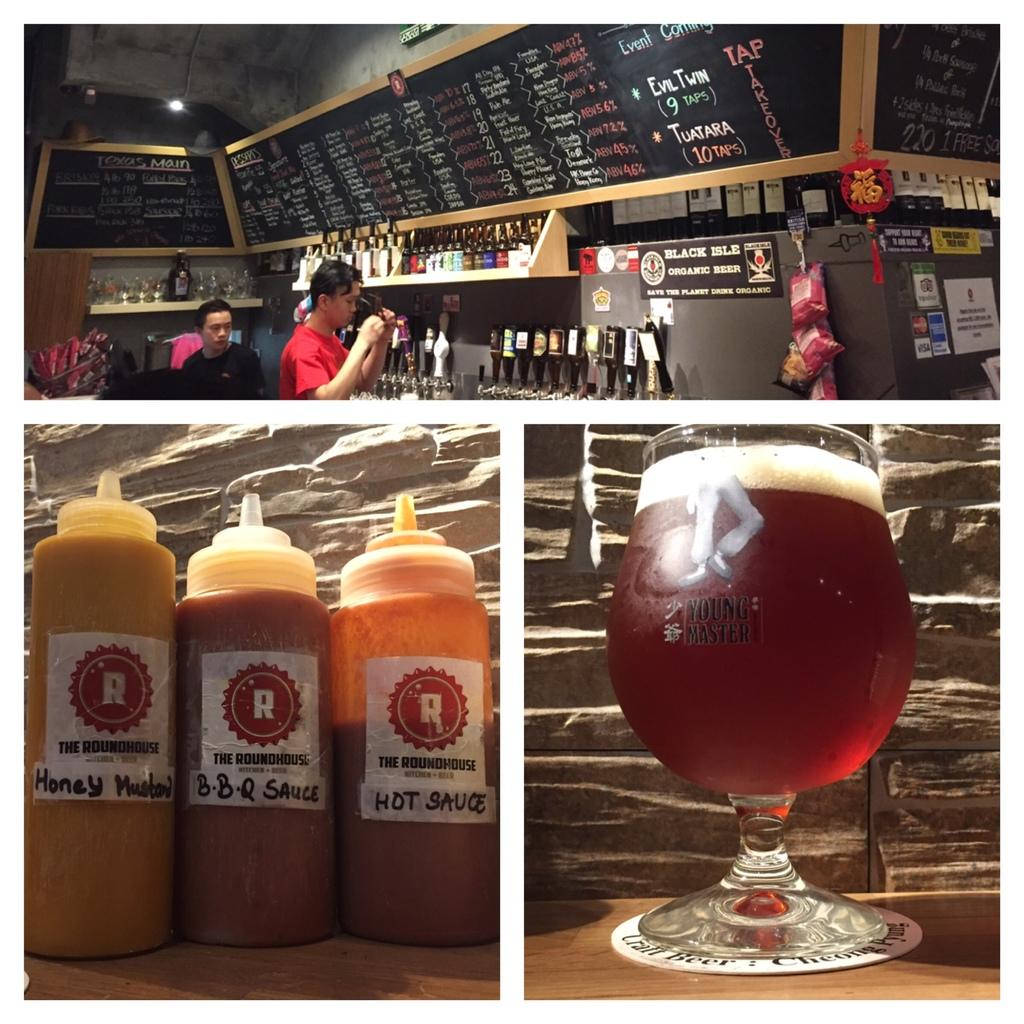<image>
Summarize the visual content of the image. Drink and sauces, honey mustard, bbq sauce and hot sauce offered at this bar. 